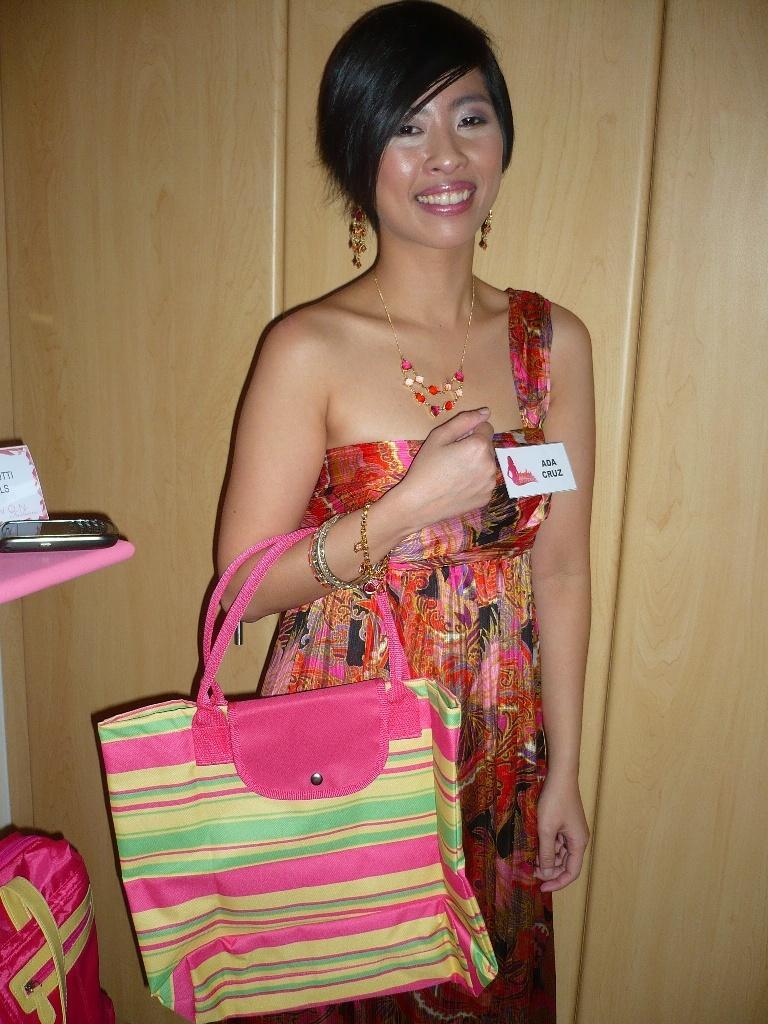Describe this image in one or two sentences. In the center we can see one woman she is smiling and one holding bag. And back we can see one more bag in pink color,phone and some more objects. 